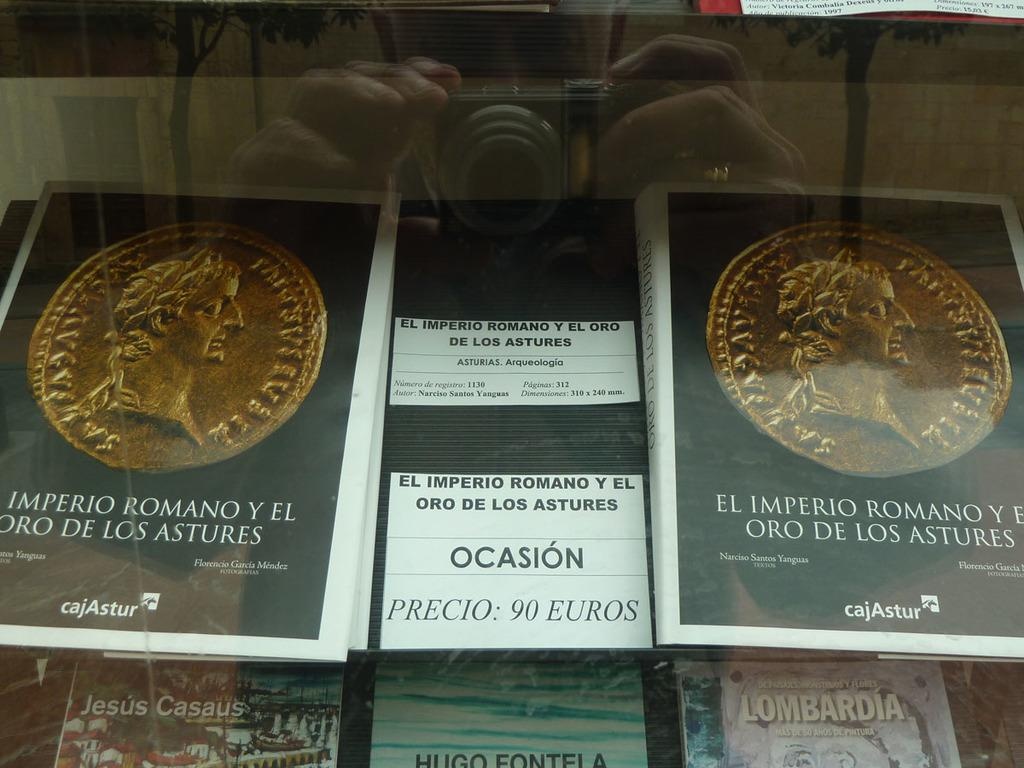<image>
Share a concise interpretation of the image provided. A display of periodical type items contain a sign with a 90 Euros price tag. 